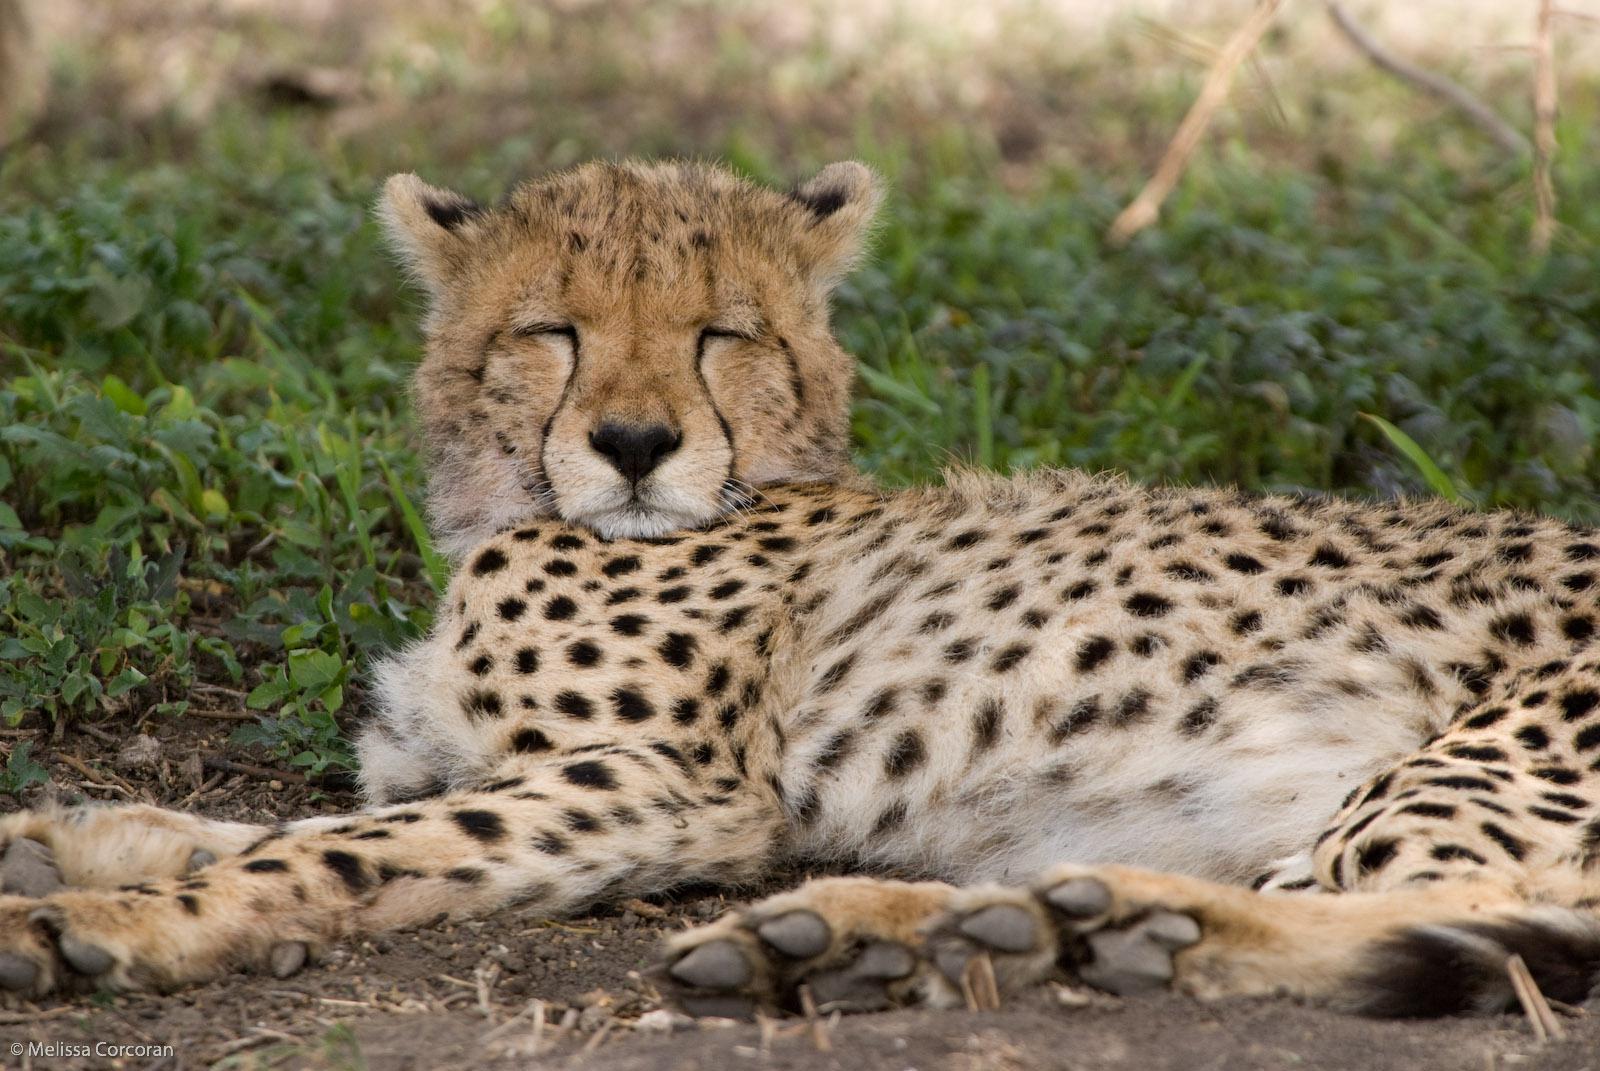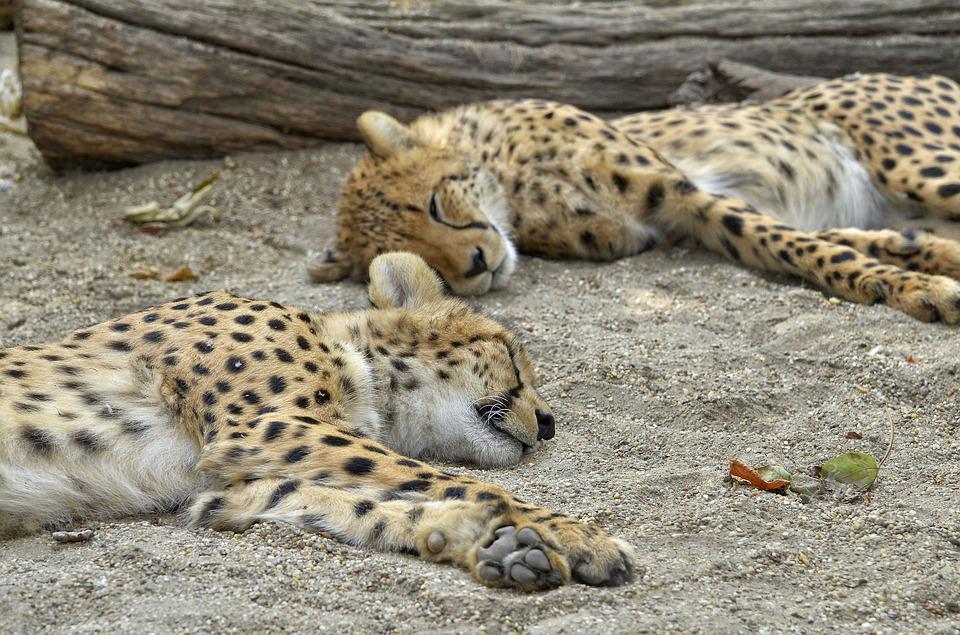The first image is the image on the left, the second image is the image on the right. Given the left and right images, does the statement "There are at most 2 cheetahs in the image pair" hold true? Answer yes or no. No. The first image is the image on the left, the second image is the image on the right. Considering the images on both sides, is "Each image shows a single cheetah." valid? Answer yes or no. No. 